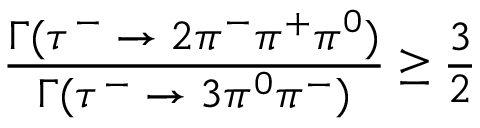<formula> <loc_0><loc_0><loc_500><loc_500>{ \frac { \Gamma ( \tau ^ { - } \to 2 \pi ^ { - } \pi ^ { + } \pi ^ { 0 } ) } { \Gamma ( \tau ^ { - } \to 3 \pi ^ { 0 } \pi ^ { - } ) } } \geq { \frac { 3 } { 2 } }</formula> 